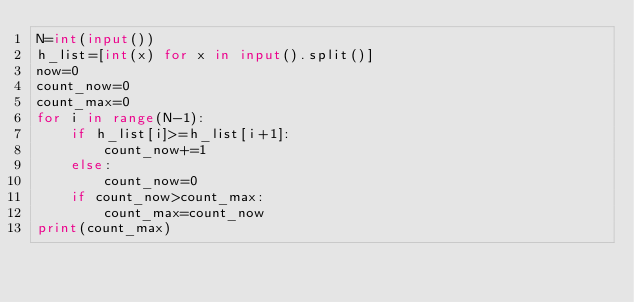Convert code to text. <code><loc_0><loc_0><loc_500><loc_500><_Python_>N=int(input())
h_list=[int(x) for x in input().split()]
now=0
count_now=0
count_max=0
for i in range(N-1):
    if h_list[i]>=h_list[i+1]:
        count_now+=1        
    else:
        count_now=0
    if count_now>count_max:
        count_max=count_now  
print(count_max)</code> 